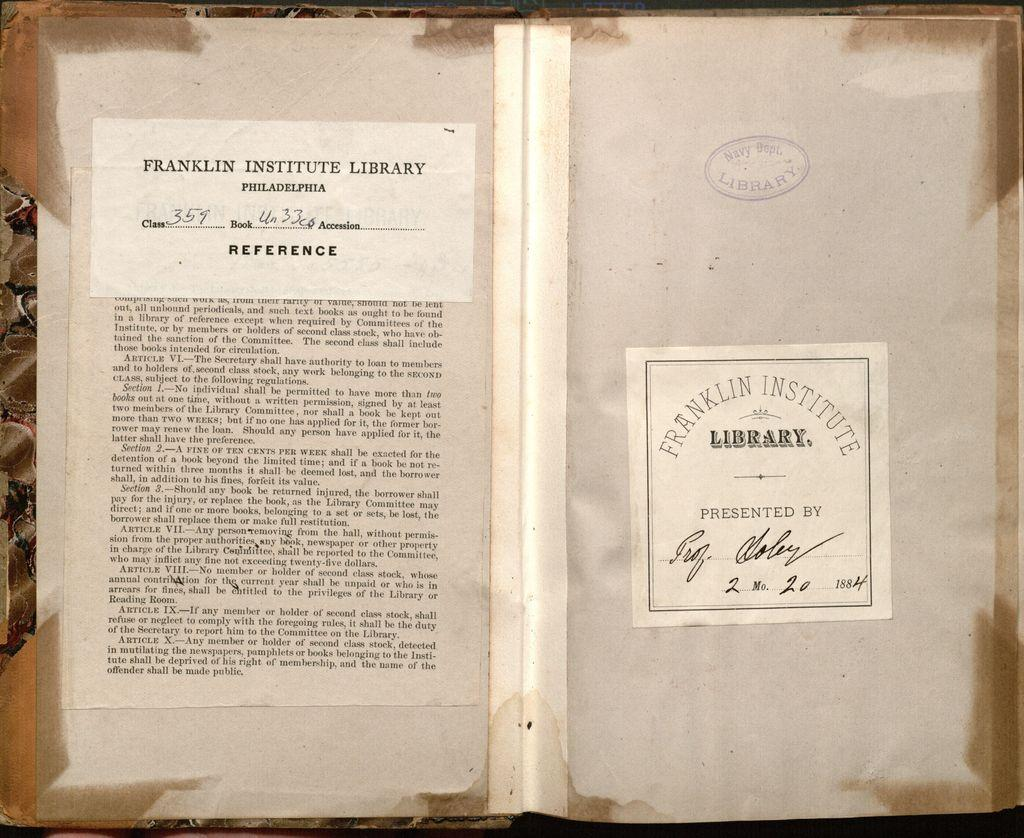<image>
Create a compact narrative representing the image presented. a book that appears to have been checked out from the franklin institute library 